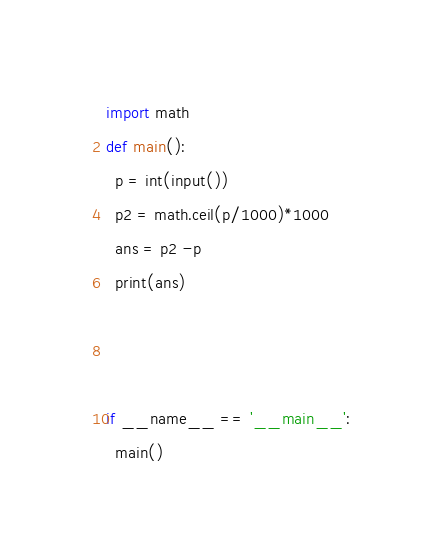<code> <loc_0><loc_0><loc_500><loc_500><_Python_>import math
def main():
  p = int(input())
  p2 = math.ceil(p/1000)*1000
  ans = p2 -p
  print(ans)
  
  
  
if __name__ == '__main__':
  main()</code> 